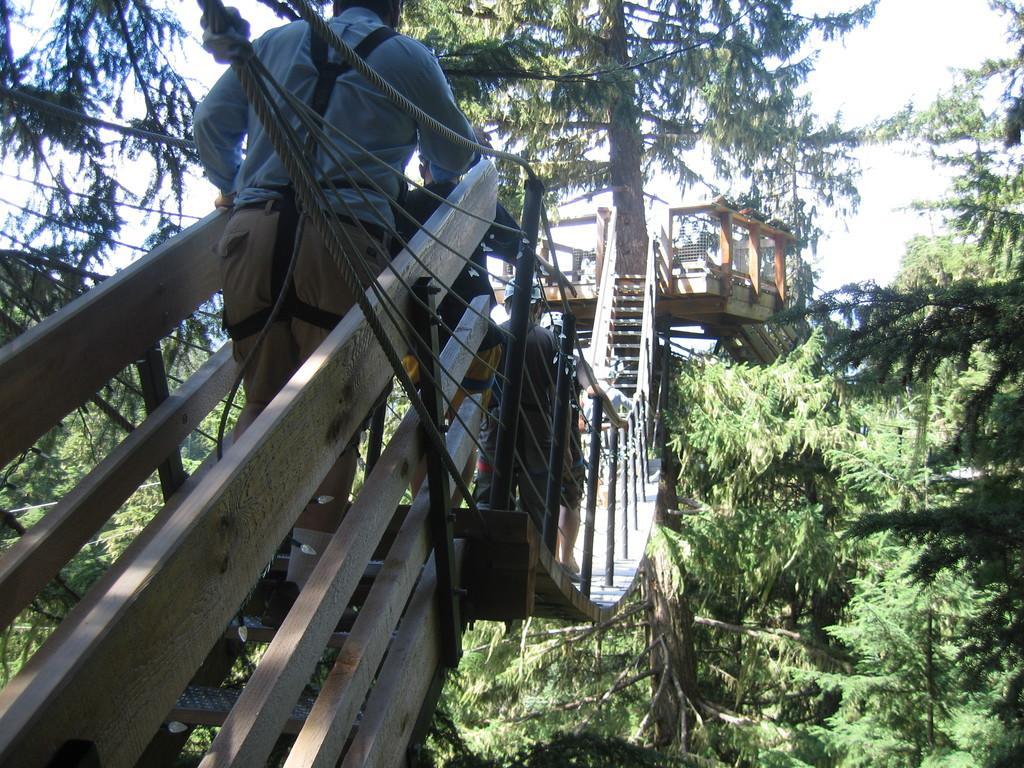Can you describe this image briefly? On the left side of the image, we can see a person on the stairs. In the middle of the image, we can see people on the bridge. In the background, there are so many trees, ropes, stairs, wooden objects, mesh and the sky. 